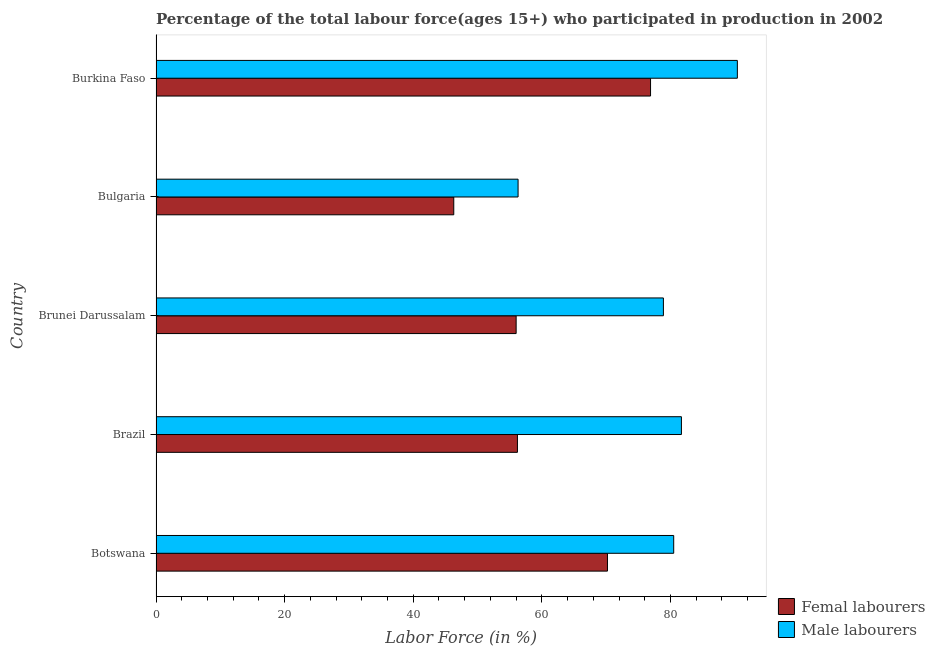How many different coloured bars are there?
Provide a succinct answer. 2. Are the number of bars per tick equal to the number of legend labels?
Offer a terse response. Yes. How many bars are there on the 5th tick from the top?
Keep it short and to the point. 2. How many bars are there on the 5th tick from the bottom?
Offer a very short reply. 2. What is the label of the 3rd group of bars from the top?
Make the answer very short. Brunei Darussalam. What is the percentage of female labor force in Brunei Darussalam?
Offer a terse response. 56. Across all countries, what is the maximum percentage of female labor force?
Provide a succinct answer. 76.9. Across all countries, what is the minimum percentage of male labour force?
Your answer should be compact. 56.3. In which country was the percentage of female labor force maximum?
Your answer should be very brief. Burkina Faso. What is the total percentage of female labor force in the graph?
Offer a terse response. 305.6. What is the difference between the percentage of female labor force in Bulgaria and that in Burkina Faso?
Provide a short and direct response. -30.6. What is the difference between the percentage of male labour force in Botswana and the percentage of female labor force in Bulgaria?
Your response must be concise. 34.2. What is the average percentage of female labor force per country?
Ensure brevity in your answer.  61.12. In how many countries, is the percentage of male labour force greater than 32 %?
Ensure brevity in your answer.  5. What is the ratio of the percentage of male labour force in Botswana to that in Burkina Faso?
Your answer should be very brief. 0.89. Is the percentage of male labour force in Brazil less than that in Bulgaria?
Offer a terse response. No. What is the difference between the highest and the second highest percentage of female labor force?
Provide a short and direct response. 6.7. What is the difference between the highest and the lowest percentage of female labor force?
Give a very brief answer. 30.6. In how many countries, is the percentage of female labor force greater than the average percentage of female labor force taken over all countries?
Provide a short and direct response. 2. Is the sum of the percentage of female labor force in Botswana and Burkina Faso greater than the maximum percentage of male labour force across all countries?
Your answer should be compact. Yes. What does the 2nd bar from the top in Bulgaria represents?
Offer a very short reply. Femal labourers. What does the 1st bar from the bottom in Brazil represents?
Provide a short and direct response. Femal labourers. How many bars are there?
Give a very brief answer. 10. What is the difference between two consecutive major ticks on the X-axis?
Your answer should be very brief. 20. Does the graph contain any zero values?
Provide a short and direct response. No. Does the graph contain grids?
Give a very brief answer. No. Where does the legend appear in the graph?
Your response must be concise. Bottom right. How are the legend labels stacked?
Make the answer very short. Vertical. What is the title of the graph?
Keep it short and to the point. Percentage of the total labour force(ages 15+) who participated in production in 2002. What is the label or title of the X-axis?
Offer a terse response. Labor Force (in %). What is the Labor Force (in %) of Femal labourers in Botswana?
Keep it short and to the point. 70.2. What is the Labor Force (in %) in Male labourers in Botswana?
Your response must be concise. 80.5. What is the Labor Force (in %) of Femal labourers in Brazil?
Provide a short and direct response. 56.2. What is the Labor Force (in %) in Male labourers in Brazil?
Make the answer very short. 81.7. What is the Labor Force (in %) of Male labourers in Brunei Darussalam?
Your response must be concise. 78.9. What is the Labor Force (in %) in Femal labourers in Bulgaria?
Your response must be concise. 46.3. What is the Labor Force (in %) of Male labourers in Bulgaria?
Offer a terse response. 56.3. What is the Labor Force (in %) of Femal labourers in Burkina Faso?
Provide a succinct answer. 76.9. What is the Labor Force (in %) of Male labourers in Burkina Faso?
Your answer should be compact. 90.4. Across all countries, what is the maximum Labor Force (in %) in Femal labourers?
Your answer should be very brief. 76.9. Across all countries, what is the maximum Labor Force (in %) in Male labourers?
Make the answer very short. 90.4. Across all countries, what is the minimum Labor Force (in %) in Femal labourers?
Offer a very short reply. 46.3. Across all countries, what is the minimum Labor Force (in %) in Male labourers?
Your answer should be very brief. 56.3. What is the total Labor Force (in %) in Femal labourers in the graph?
Your response must be concise. 305.6. What is the total Labor Force (in %) in Male labourers in the graph?
Your answer should be very brief. 387.8. What is the difference between the Labor Force (in %) of Femal labourers in Botswana and that in Brazil?
Make the answer very short. 14. What is the difference between the Labor Force (in %) in Male labourers in Botswana and that in Brazil?
Your answer should be very brief. -1.2. What is the difference between the Labor Force (in %) in Femal labourers in Botswana and that in Brunei Darussalam?
Provide a short and direct response. 14.2. What is the difference between the Labor Force (in %) in Male labourers in Botswana and that in Brunei Darussalam?
Provide a succinct answer. 1.6. What is the difference between the Labor Force (in %) in Femal labourers in Botswana and that in Bulgaria?
Offer a very short reply. 23.9. What is the difference between the Labor Force (in %) of Male labourers in Botswana and that in Bulgaria?
Ensure brevity in your answer.  24.2. What is the difference between the Labor Force (in %) of Male labourers in Brazil and that in Brunei Darussalam?
Your answer should be compact. 2.8. What is the difference between the Labor Force (in %) in Male labourers in Brazil and that in Bulgaria?
Provide a succinct answer. 25.4. What is the difference between the Labor Force (in %) in Femal labourers in Brazil and that in Burkina Faso?
Your answer should be very brief. -20.7. What is the difference between the Labor Force (in %) of Male labourers in Brazil and that in Burkina Faso?
Make the answer very short. -8.7. What is the difference between the Labor Force (in %) of Male labourers in Brunei Darussalam and that in Bulgaria?
Offer a terse response. 22.6. What is the difference between the Labor Force (in %) of Femal labourers in Brunei Darussalam and that in Burkina Faso?
Ensure brevity in your answer.  -20.9. What is the difference between the Labor Force (in %) in Femal labourers in Bulgaria and that in Burkina Faso?
Offer a terse response. -30.6. What is the difference between the Labor Force (in %) of Male labourers in Bulgaria and that in Burkina Faso?
Your answer should be very brief. -34.1. What is the difference between the Labor Force (in %) of Femal labourers in Botswana and the Labor Force (in %) of Male labourers in Brazil?
Offer a very short reply. -11.5. What is the difference between the Labor Force (in %) in Femal labourers in Botswana and the Labor Force (in %) in Male labourers in Brunei Darussalam?
Offer a very short reply. -8.7. What is the difference between the Labor Force (in %) of Femal labourers in Botswana and the Labor Force (in %) of Male labourers in Bulgaria?
Make the answer very short. 13.9. What is the difference between the Labor Force (in %) in Femal labourers in Botswana and the Labor Force (in %) in Male labourers in Burkina Faso?
Your answer should be compact. -20.2. What is the difference between the Labor Force (in %) of Femal labourers in Brazil and the Labor Force (in %) of Male labourers in Brunei Darussalam?
Offer a terse response. -22.7. What is the difference between the Labor Force (in %) of Femal labourers in Brazil and the Labor Force (in %) of Male labourers in Bulgaria?
Ensure brevity in your answer.  -0.1. What is the difference between the Labor Force (in %) in Femal labourers in Brazil and the Labor Force (in %) in Male labourers in Burkina Faso?
Your response must be concise. -34.2. What is the difference between the Labor Force (in %) in Femal labourers in Brunei Darussalam and the Labor Force (in %) in Male labourers in Bulgaria?
Ensure brevity in your answer.  -0.3. What is the difference between the Labor Force (in %) of Femal labourers in Brunei Darussalam and the Labor Force (in %) of Male labourers in Burkina Faso?
Provide a succinct answer. -34.4. What is the difference between the Labor Force (in %) of Femal labourers in Bulgaria and the Labor Force (in %) of Male labourers in Burkina Faso?
Make the answer very short. -44.1. What is the average Labor Force (in %) of Femal labourers per country?
Provide a short and direct response. 61.12. What is the average Labor Force (in %) of Male labourers per country?
Your response must be concise. 77.56. What is the difference between the Labor Force (in %) in Femal labourers and Labor Force (in %) in Male labourers in Brazil?
Offer a very short reply. -25.5. What is the difference between the Labor Force (in %) of Femal labourers and Labor Force (in %) of Male labourers in Brunei Darussalam?
Offer a very short reply. -22.9. What is the difference between the Labor Force (in %) of Femal labourers and Labor Force (in %) of Male labourers in Burkina Faso?
Your answer should be compact. -13.5. What is the ratio of the Labor Force (in %) of Femal labourers in Botswana to that in Brazil?
Your answer should be very brief. 1.25. What is the ratio of the Labor Force (in %) in Male labourers in Botswana to that in Brazil?
Offer a very short reply. 0.99. What is the ratio of the Labor Force (in %) in Femal labourers in Botswana to that in Brunei Darussalam?
Ensure brevity in your answer.  1.25. What is the ratio of the Labor Force (in %) of Male labourers in Botswana to that in Brunei Darussalam?
Keep it short and to the point. 1.02. What is the ratio of the Labor Force (in %) of Femal labourers in Botswana to that in Bulgaria?
Make the answer very short. 1.52. What is the ratio of the Labor Force (in %) of Male labourers in Botswana to that in Bulgaria?
Provide a succinct answer. 1.43. What is the ratio of the Labor Force (in %) in Femal labourers in Botswana to that in Burkina Faso?
Give a very brief answer. 0.91. What is the ratio of the Labor Force (in %) of Male labourers in Botswana to that in Burkina Faso?
Ensure brevity in your answer.  0.89. What is the ratio of the Labor Force (in %) of Male labourers in Brazil to that in Brunei Darussalam?
Your answer should be very brief. 1.04. What is the ratio of the Labor Force (in %) of Femal labourers in Brazil to that in Bulgaria?
Offer a very short reply. 1.21. What is the ratio of the Labor Force (in %) of Male labourers in Brazil to that in Bulgaria?
Ensure brevity in your answer.  1.45. What is the ratio of the Labor Force (in %) of Femal labourers in Brazil to that in Burkina Faso?
Keep it short and to the point. 0.73. What is the ratio of the Labor Force (in %) in Male labourers in Brazil to that in Burkina Faso?
Provide a short and direct response. 0.9. What is the ratio of the Labor Force (in %) of Femal labourers in Brunei Darussalam to that in Bulgaria?
Ensure brevity in your answer.  1.21. What is the ratio of the Labor Force (in %) in Male labourers in Brunei Darussalam to that in Bulgaria?
Ensure brevity in your answer.  1.4. What is the ratio of the Labor Force (in %) in Femal labourers in Brunei Darussalam to that in Burkina Faso?
Offer a terse response. 0.73. What is the ratio of the Labor Force (in %) of Male labourers in Brunei Darussalam to that in Burkina Faso?
Offer a terse response. 0.87. What is the ratio of the Labor Force (in %) in Femal labourers in Bulgaria to that in Burkina Faso?
Your response must be concise. 0.6. What is the ratio of the Labor Force (in %) of Male labourers in Bulgaria to that in Burkina Faso?
Your answer should be compact. 0.62. What is the difference between the highest and the second highest Labor Force (in %) in Femal labourers?
Ensure brevity in your answer.  6.7. What is the difference between the highest and the lowest Labor Force (in %) in Femal labourers?
Provide a short and direct response. 30.6. What is the difference between the highest and the lowest Labor Force (in %) in Male labourers?
Keep it short and to the point. 34.1. 